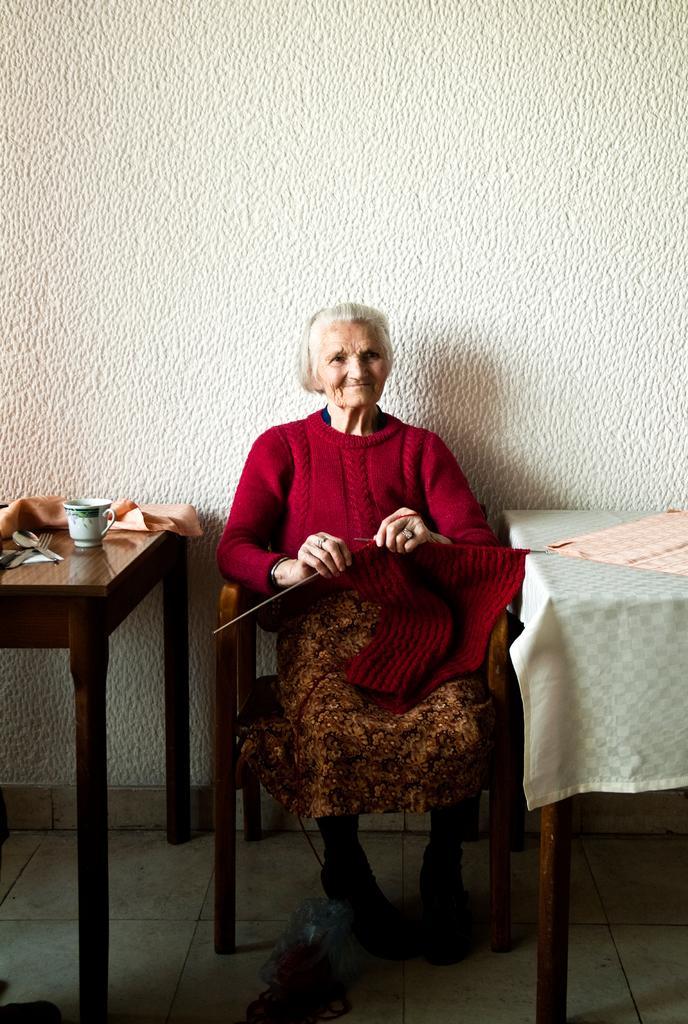In one or two sentences, can you explain what this image depicts? Here is the old woman sitting on the chair and smiling. She is sewing with woolen cloth using needles. This is a table covered with cloth,and here is another table with a cup,spoons and cloth on it. This is wall which is white in color. 